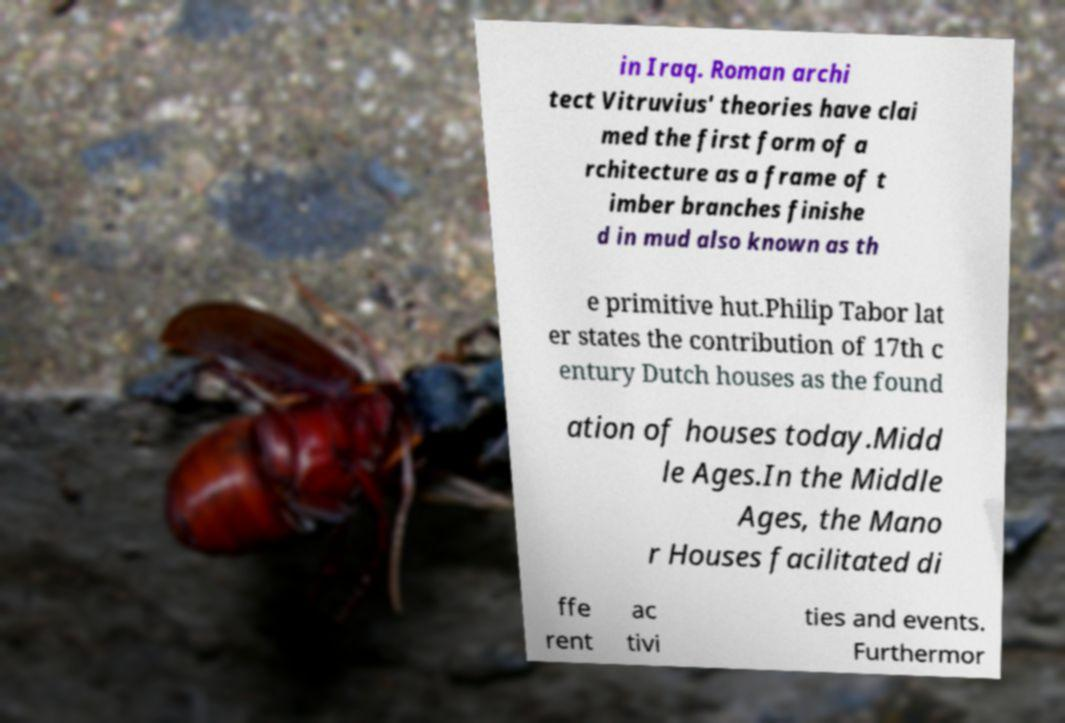What messages or text are displayed in this image? I need them in a readable, typed format. in Iraq. Roman archi tect Vitruvius' theories have clai med the first form of a rchitecture as a frame of t imber branches finishe d in mud also known as th e primitive hut.Philip Tabor lat er states the contribution of 17th c entury Dutch houses as the found ation of houses today.Midd le Ages.In the Middle Ages, the Mano r Houses facilitated di ffe rent ac tivi ties and events. Furthermor 